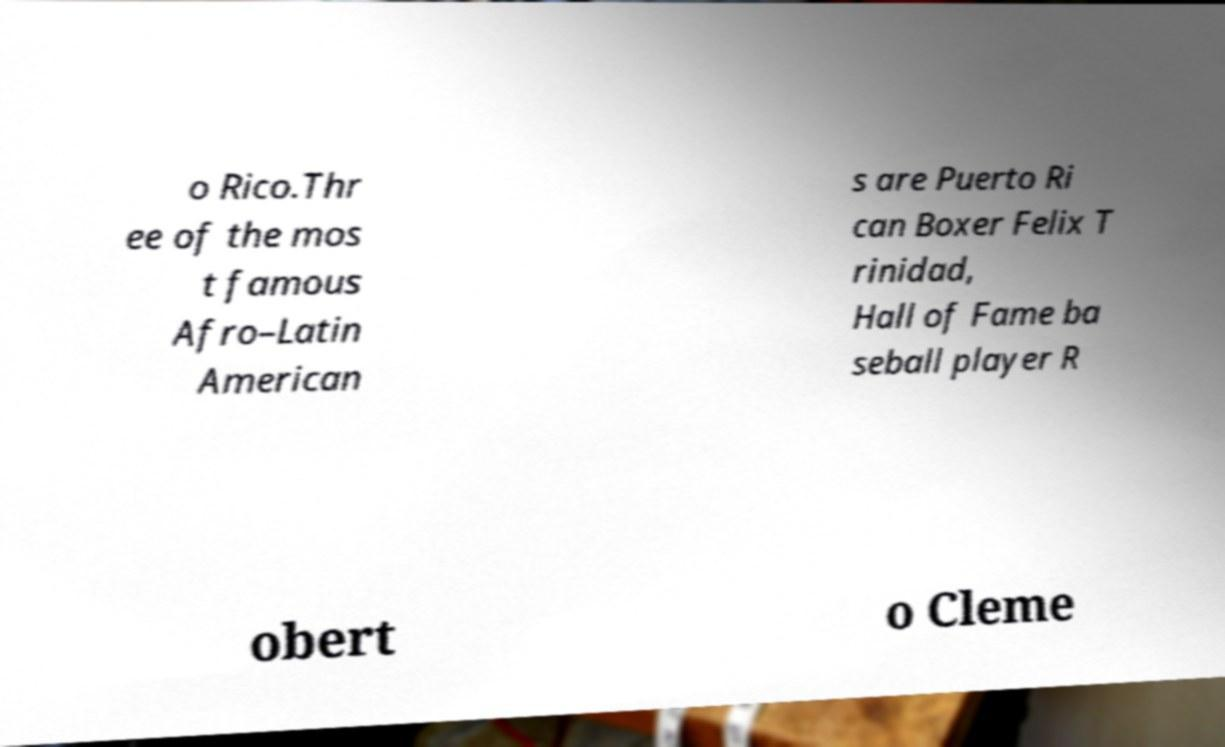Please identify and transcribe the text found in this image. o Rico.Thr ee of the mos t famous Afro–Latin American s are Puerto Ri can Boxer Felix T rinidad, Hall of Fame ba seball player R obert o Cleme 